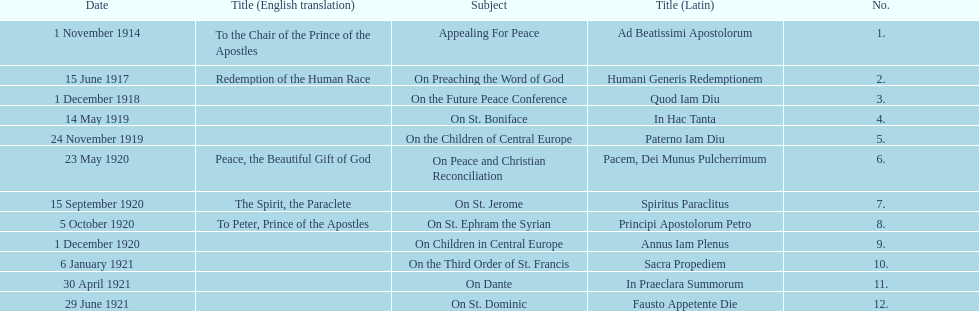What was the number of encyclopedias that had subjects relating specifically to children? 2. 